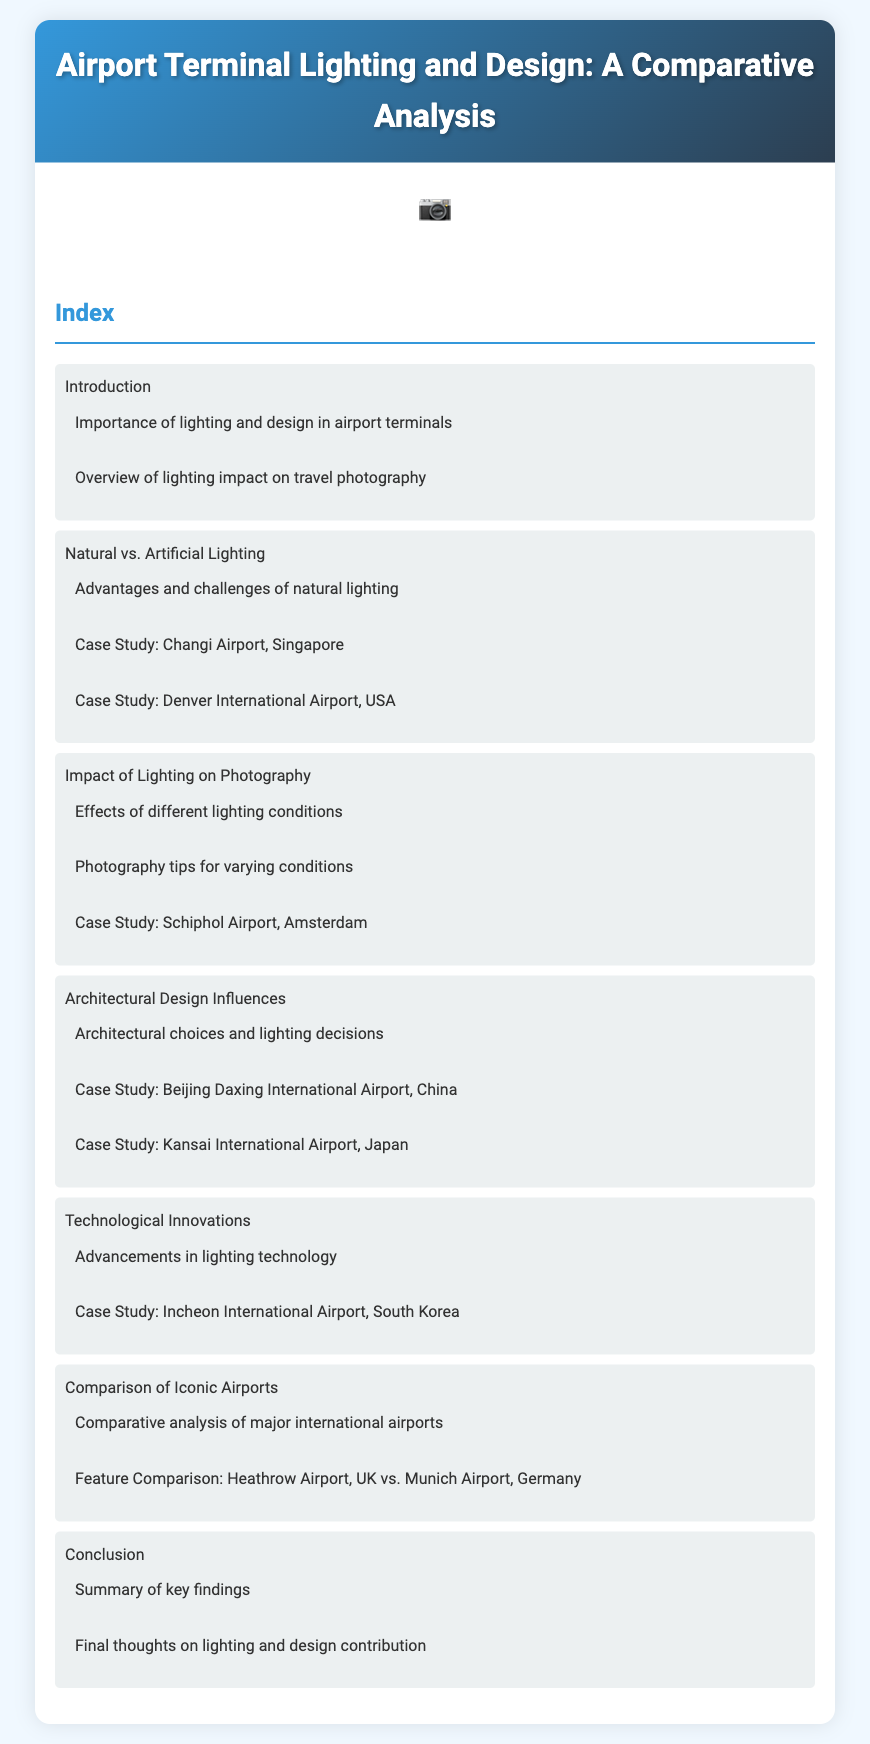What is a key factor discussed in the introduction? The introduction outlines the importance of lighting and design in airport terminals.
Answer: Importance of lighting and design Which airport is highlighted as a case study for natural lighting? A case study on natural lighting features Changi Airport, Singapore.
Answer: Changi Airport, Singapore What type of lighting is compared in the second section? The second section compares natural and artificial lighting in airport terminals.
Answer: Natural vs. Artificial Lighting Which airport serves as a case study for advancements in lighting technology? In the section on technological innovations, Incheon International Airport is analyzed.
Answer: Incheon International Airport, South Korea How many case studies are included in the architectural design influences section? The architectural design influences section contains three case studies.
Answer: Three What does the conclusion summarize? The conclusion provides a summary of key findings and final thoughts on lighting and design contribution.
Answer: Key findings What two airports are compared in the feature comparison? The comparison analyzes Heathrow Airport and Munich Airport.
Answer: Heathrow Airport, UK vs. Munich Airport, Germany What aspect does the document suggest impacts travel photography? The document discusses the impact of lighting on travel photography.
Answer: Impact of Lighting on Photography 